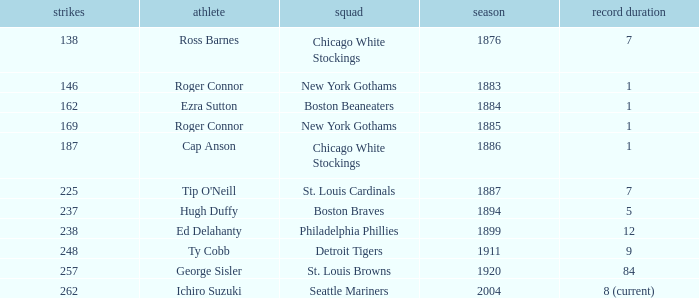What were some hit songs from the years prior to 1883? 138.0. 